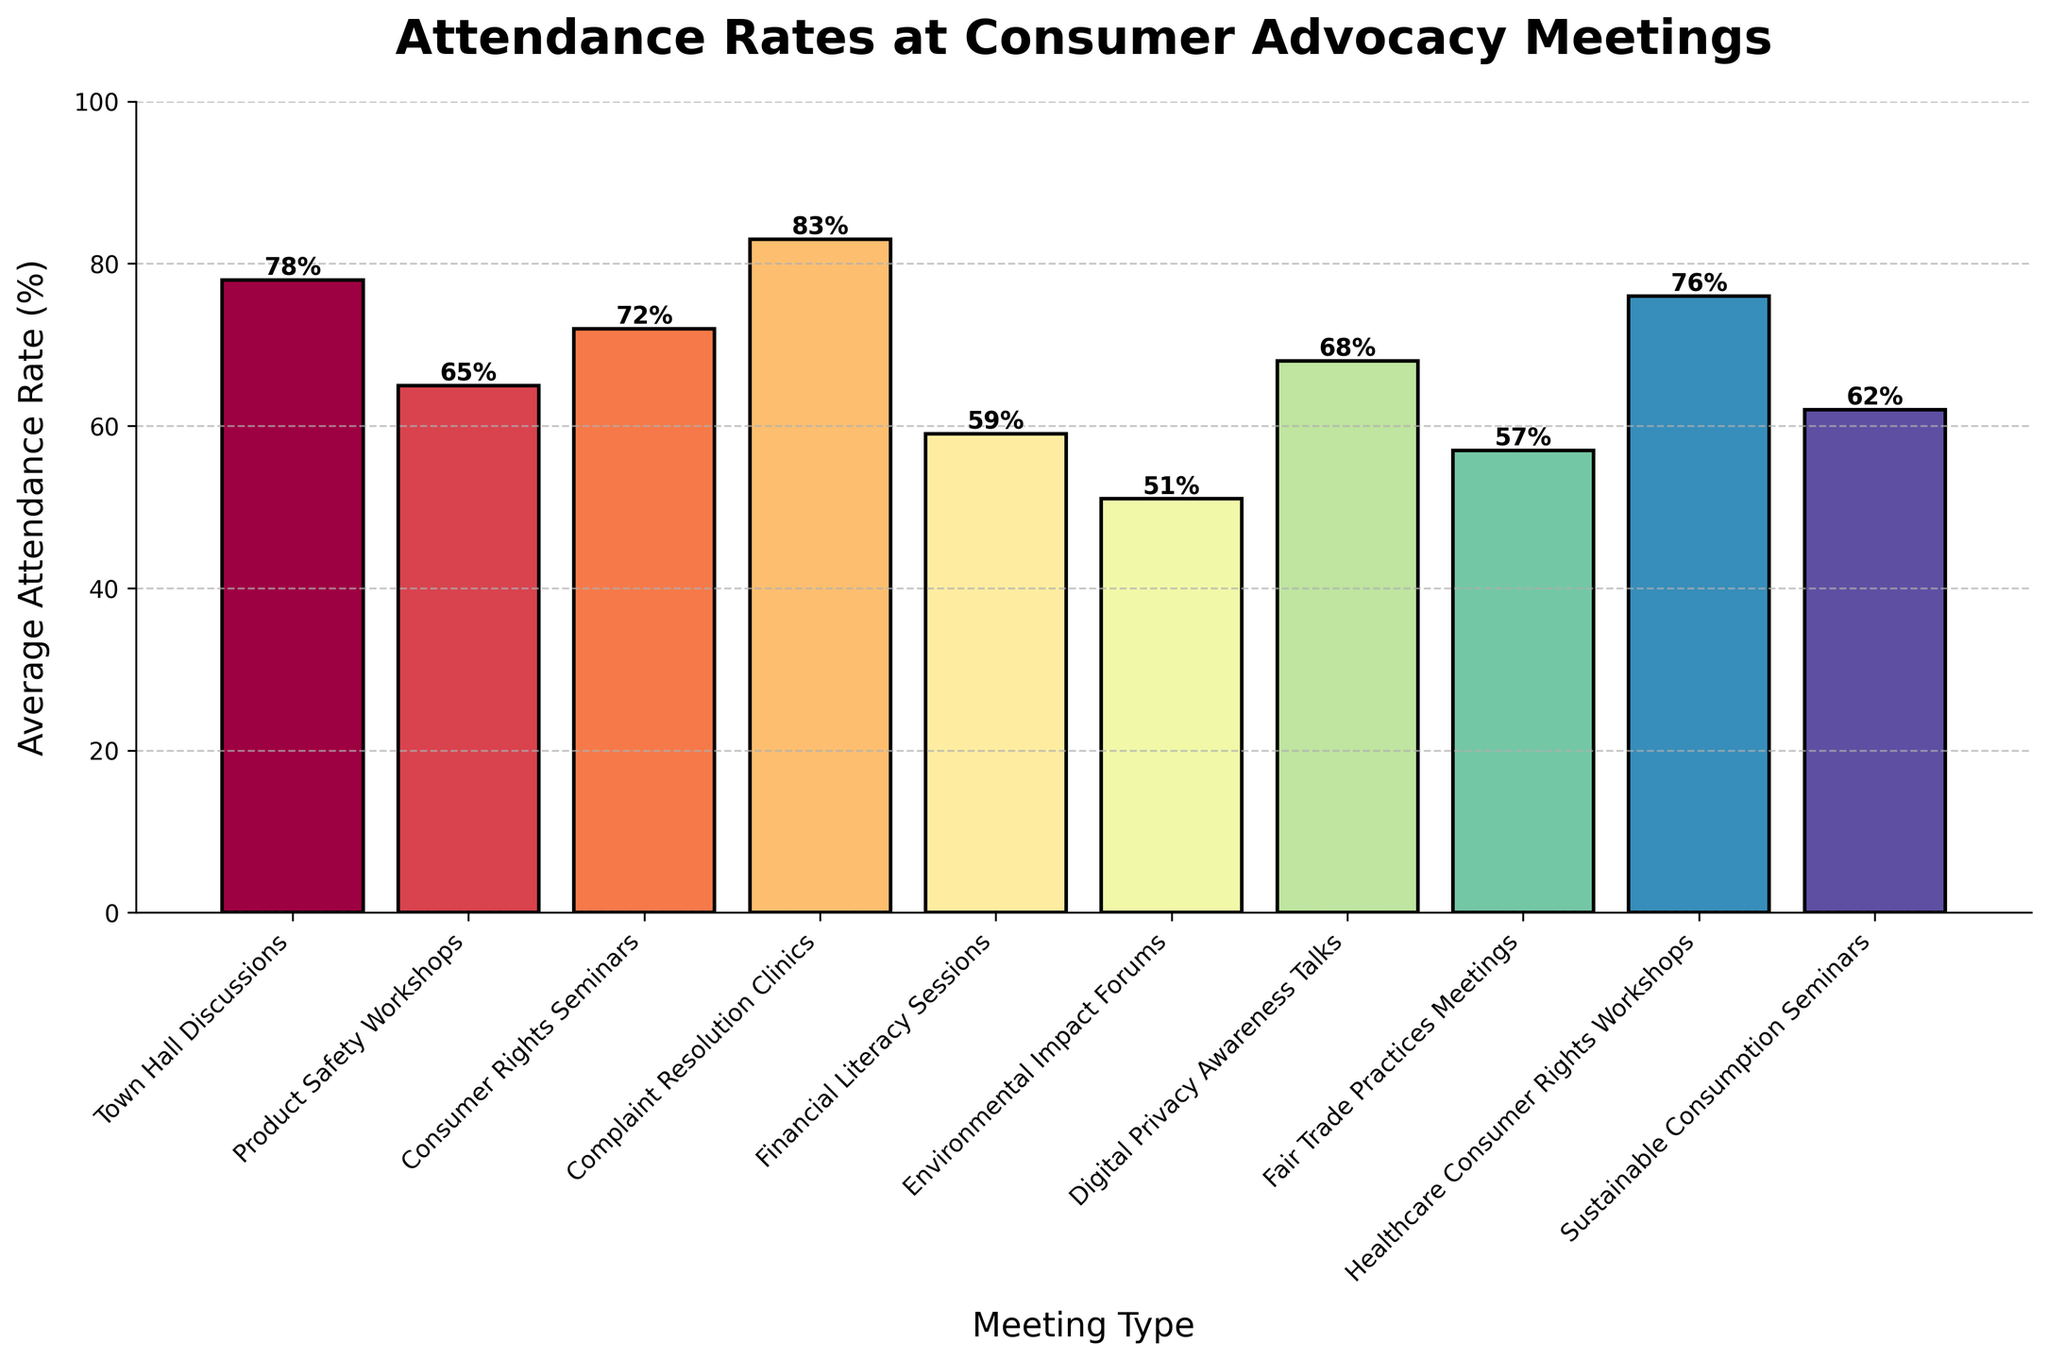What's the meeting type with the highest average attendance rate? The tallest bar indicates the highest average attendance rate. The tallest bar corresponds to "Complaint Resolution Clinics."
Answer: Complaint Resolution Clinics Which meeting type has the lowest average attendance rate? The shortest bar indicates the lowest average attendance rate. The shortest bar corresponds to "Environmental Impact Forums."
Answer: Environmental Impact Forums By how much does the average attendance rate of "Complaint Resolution Clinics" exceed that of "Financial Literacy Sessions"? "Complaint Resolution Clinics" have an average attendance rate of 83%, while "Financial Literacy Sessions" have an average attendance rate of 59%. The difference is 83% - 59% = 24%.
Answer: 24% What's the combined average attendance rate for "Town Hall Discussions" and "Healthcare Consumer Rights Workshops"? "Town Hall Discussions" have an average attendance rate of 78%, and "Healthcare Consumer Rights Workshops" have an average attendance rate of 76%. The combined rate is 78% + 76% = 154%.
Answer: 154% How many meeting types have an average attendance rate of 70% or higher? Count the bars that reach 70% or more on the y-axis. The meeting types are "Town Hall Discussions," "Consumer Rights Seminars," "Complaint Resolution Clinics," and "Healthcare Consumer Rights Workshops," totaling 4.
Answer: 4 Which has a higher average attendance rate: "Digital Privacy Awareness Talks" or "Consumer Rights Seminars"? Compare the heights of the bars for "Digital Privacy Awareness Talks" (68%) and "Consumer Rights Seminars" (72%). "Consumer Rights Seminars" have a higher average attendance rate.
Answer: Consumer Rights Seminars What is the difference in average attendance rates between the highest and lowest meeting types? The highest is "Complaint Resolution Clinics" at 83%, and the lowest is "Environmental Impact Forums" at 51%. The difference is 83% - 51% = 32%.
Answer: 32% What is the mean attendance rate for all the meeting types? Sum all the average attendance rates: (78 + 65 + 72 + 83 + 59 + 51 + 68 + 57 + 76 + 62) = 671. Divide by the number of meeting types (10). The mean rate is 671 / 10 = 67.1%.
Answer: 67.1% Which meeting types have attendance rates between 60% and 70%? Identify the bars within the 60%-70% range. The meeting types are "Product Safety Workshops" (65%), "Digital Privacy Awareness Talks" (68%), and "Sustainable Consumption Seminars" (62%).
Answer: Product Safety Workshops, Digital Privacy Awareness Talks, Sustainable Consumption Seminars 